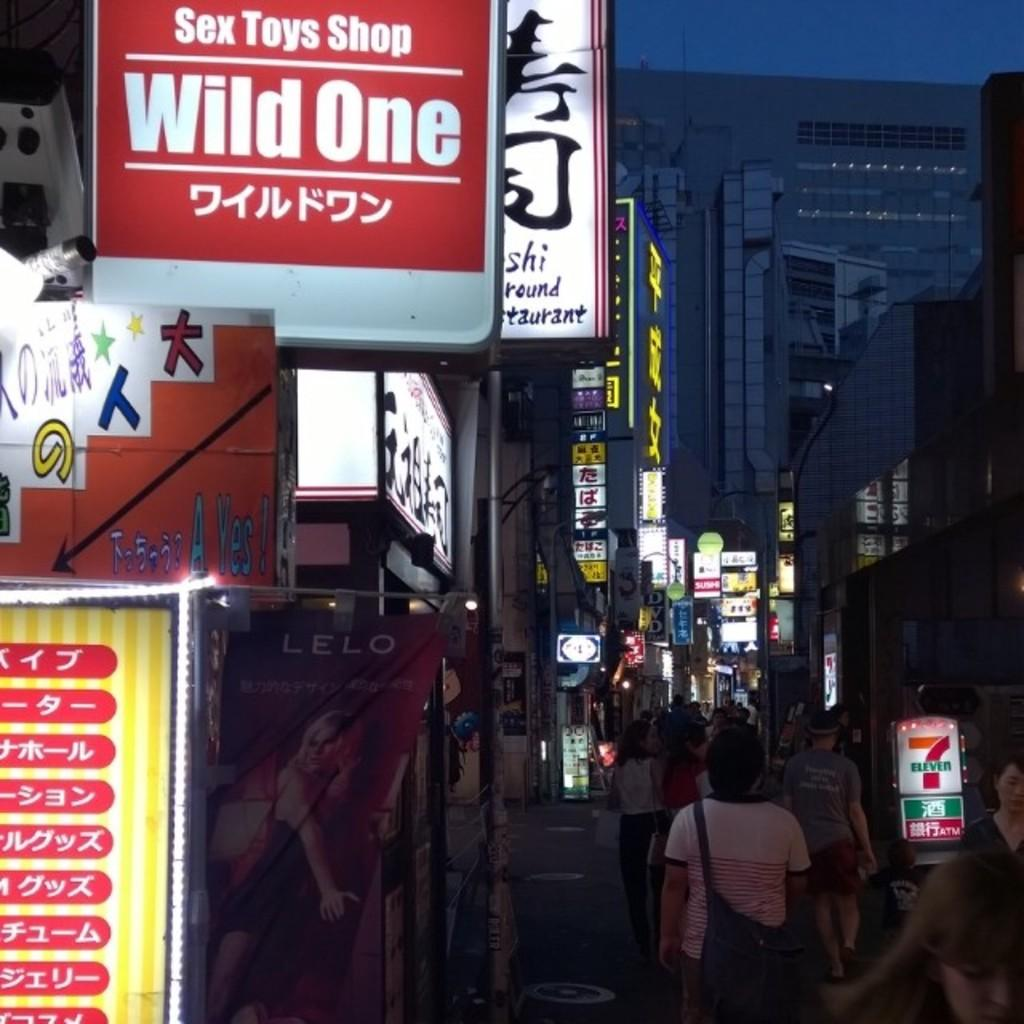<image>
Relay a brief, clear account of the picture shown. A city street with people walking and signs above head, one of which reads Toys Shop. 